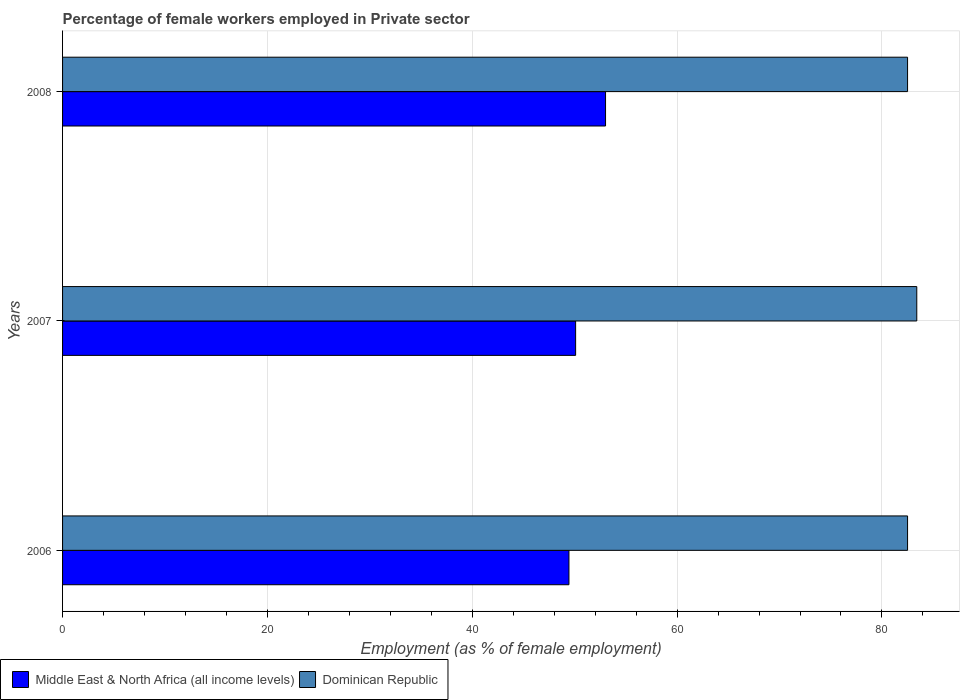How many groups of bars are there?
Make the answer very short. 3. How many bars are there on the 3rd tick from the top?
Ensure brevity in your answer.  2. How many bars are there on the 2nd tick from the bottom?
Your answer should be very brief. 2. In how many cases, is the number of bars for a given year not equal to the number of legend labels?
Make the answer very short. 0. What is the percentage of females employed in Private sector in Middle East & North Africa (all income levels) in 2007?
Provide a succinct answer. 50.09. Across all years, what is the maximum percentage of females employed in Private sector in Dominican Republic?
Provide a short and direct response. 83.4. Across all years, what is the minimum percentage of females employed in Private sector in Dominican Republic?
Ensure brevity in your answer.  82.5. In which year was the percentage of females employed in Private sector in Middle East & North Africa (all income levels) maximum?
Ensure brevity in your answer.  2008. In which year was the percentage of females employed in Private sector in Dominican Republic minimum?
Offer a terse response. 2006. What is the total percentage of females employed in Private sector in Middle East & North Africa (all income levels) in the graph?
Your response must be concise. 152.54. What is the difference between the percentage of females employed in Private sector in Middle East & North Africa (all income levels) in 2007 and that in 2008?
Offer a very short reply. -2.92. What is the difference between the percentage of females employed in Private sector in Dominican Republic in 2006 and the percentage of females employed in Private sector in Middle East & North Africa (all income levels) in 2008?
Offer a very short reply. 29.49. What is the average percentage of females employed in Private sector in Middle East & North Africa (all income levels) per year?
Your answer should be compact. 50.85. In the year 2008, what is the difference between the percentage of females employed in Private sector in Dominican Republic and percentage of females employed in Private sector in Middle East & North Africa (all income levels)?
Offer a terse response. 29.49. In how many years, is the percentage of females employed in Private sector in Dominican Republic greater than 44 %?
Your answer should be compact. 3. What is the ratio of the percentage of females employed in Private sector in Middle East & North Africa (all income levels) in 2006 to that in 2007?
Provide a short and direct response. 0.99. Is the difference between the percentage of females employed in Private sector in Dominican Republic in 2006 and 2007 greater than the difference between the percentage of females employed in Private sector in Middle East & North Africa (all income levels) in 2006 and 2007?
Your answer should be compact. No. What is the difference between the highest and the second highest percentage of females employed in Private sector in Middle East & North Africa (all income levels)?
Make the answer very short. 2.92. What is the difference between the highest and the lowest percentage of females employed in Private sector in Middle East & North Africa (all income levels)?
Provide a short and direct response. 3.57. In how many years, is the percentage of females employed in Private sector in Dominican Republic greater than the average percentage of females employed in Private sector in Dominican Republic taken over all years?
Give a very brief answer. 1. Is the sum of the percentage of females employed in Private sector in Middle East & North Africa (all income levels) in 2006 and 2007 greater than the maximum percentage of females employed in Private sector in Dominican Republic across all years?
Provide a short and direct response. Yes. What does the 2nd bar from the top in 2007 represents?
Your answer should be very brief. Middle East & North Africa (all income levels). What does the 2nd bar from the bottom in 2006 represents?
Make the answer very short. Dominican Republic. How many years are there in the graph?
Ensure brevity in your answer.  3. Are the values on the major ticks of X-axis written in scientific E-notation?
Give a very brief answer. No. Does the graph contain any zero values?
Give a very brief answer. No. Where does the legend appear in the graph?
Keep it short and to the point. Bottom left. What is the title of the graph?
Offer a very short reply. Percentage of female workers employed in Private sector. What is the label or title of the X-axis?
Provide a succinct answer. Employment (as % of female employment). What is the Employment (as % of female employment) in Middle East & North Africa (all income levels) in 2006?
Give a very brief answer. 49.44. What is the Employment (as % of female employment) of Dominican Republic in 2006?
Give a very brief answer. 82.5. What is the Employment (as % of female employment) in Middle East & North Africa (all income levels) in 2007?
Offer a terse response. 50.09. What is the Employment (as % of female employment) of Dominican Republic in 2007?
Your response must be concise. 83.4. What is the Employment (as % of female employment) in Middle East & North Africa (all income levels) in 2008?
Your answer should be compact. 53.01. What is the Employment (as % of female employment) of Dominican Republic in 2008?
Give a very brief answer. 82.5. Across all years, what is the maximum Employment (as % of female employment) in Middle East & North Africa (all income levels)?
Keep it short and to the point. 53.01. Across all years, what is the maximum Employment (as % of female employment) of Dominican Republic?
Make the answer very short. 83.4. Across all years, what is the minimum Employment (as % of female employment) in Middle East & North Africa (all income levels)?
Ensure brevity in your answer.  49.44. Across all years, what is the minimum Employment (as % of female employment) in Dominican Republic?
Your answer should be very brief. 82.5. What is the total Employment (as % of female employment) in Middle East & North Africa (all income levels) in the graph?
Make the answer very short. 152.54. What is the total Employment (as % of female employment) of Dominican Republic in the graph?
Provide a short and direct response. 248.4. What is the difference between the Employment (as % of female employment) in Middle East & North Africa (all income levels) in 2006 and that in 2007?
Offer a very short reply. -0.65. What is the difference between the Employment (as % of female employment) in Dominican Republic in 2006 and that in 2007?
Your answer should be compact. -0.9. What is the difference between the Employment (as % of female employment) in Middle East & North Africa (all income levels) in 2006 and that in 2008?
Your answer should be very brief. -3.57. What is the difference between the Employment (as % of female employment) in Dominican Republic in 2006 and that in 2008?
Your answer should be compact. 0. What is the difference between the Employment (as % of female employment) in Middle East & North Africa (all income levels) in 2007 and that in 2008?
Give a very brief answer. -2.92. What is the difference between the Employment (as % of female employment) in Dominican Republic in 2007 and that in 2008?
Offer a very short reply. 0.9. What is the difference between the Employment (as % of female employment) in Middle East & North Africa (all income levels) in 2006 and the Employment (as % of female employment) in Dominican Republic in 2007?
Your answer should be compact. -33.96. What is the difference between the Employment (as % of female employment) in Middle East & North Africa (all income levels) in 2006 and the Employment (as % of female employment) in Dominican Republic in 2008?
Ensure brevity in your answer.  -33.06. What is the difference between the Employment (as % of female employment) in Middle East & North Africa (all income levels) in 2007 and the Employment (as % of female employment) in Dominican Republic in 2008?
Offer a very short reply. -32.41. What is the average Employment (as % of female employment) of Middle East & North Africa (all income levels) per year?
Your answer should be very brief. 50.85. What is the average Employment (as % of female employment) in Dominican Republic per year?
Ensure brevity in your answer.  82.8. In the year 2006, what is the difference between the Employment (as % of female employment) in Middle East & North Africa (all income levels) and Employment (as % of female employment) in Dominican Republic?
Offer a terse response. -33.06. In the year 2007, what is the difference between the Employment (as % of female employment) of Middle East & North Africa (all income levels) and Employment (as % of female employment) of Dominican Republic?
Make the answer very short. -33.31. In the year 2008, what is the difference between the Employment (as % of female employment) in Middle East & North Africa (all income levels) and Employment (as % of female employment) in Dominican Republic?
Provide a succinct answer. -29.49. What is the ratio of the Employment (as % of female employment) in Dominican Republic in 2006 to that in 2007?
Make the answer very short. 0.99. What is the ratio of the Employment (as % of female employment) in Middle East & North Africa (all income levels) in 2006 to that in 2008?
Your answer should be very brief. 0.93. What is the ratio of the Employment (as % of female employment) of Dominican Republic in 2006 to that in 2008?
Offer a very short reply. 1. What is the ratio of the Employment (as % of female employment) of Middle East & North Africa (all income levels) in 2007 to that in 2008?
Offer a terse response. 0.94. What is the ratio of the Employment (as % of female employment) of Dominican Republic in 2007 to that in 2008?
Offer a terse response. 1.01. What is the difference between the highest and the second highest Employment (as % of female employment) in Middle East & North Africa (all income levels)?
Your answer should be compact. 2.92. What is the difference between the highest and the lowest Employment (as % of female employment) of Middle East & North Africa (all income levels)?
Offer a terse response. 3.57. What is the difference between the highest and the lowest Employment (as % of female employment) in Dominican Republic?
Your answer should be very brief. 0.9. 